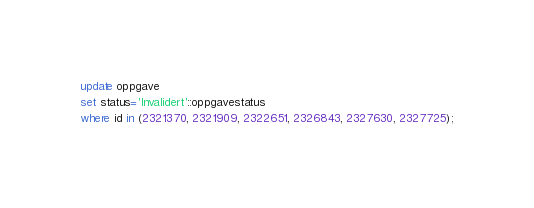<code> <loc_0><loc_0><loc_500><loc_500><_SQL_>update oppgave
set status='Invalidert'::oppgavestatus
where id in (2321370, 2321909, 2322651, 2326843, 2327630, 2327725);
</code> 